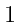Convert formula to latex. <formula><loc_0><loc_0><loc_500><loc_500>\begin{smallmatrix} & & \\ 1 & & \\ & & \end{smallmatrix}</formula> 